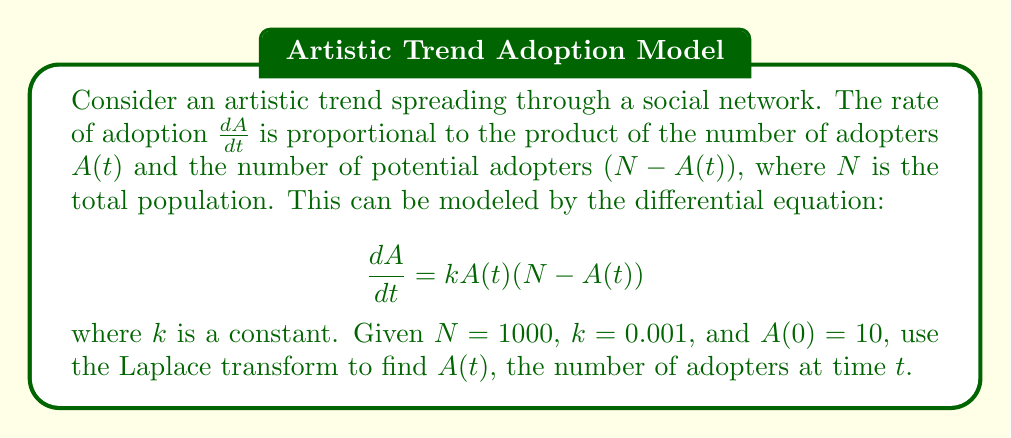Can you answer this question? Let's solve this step-by-step using the Laplace transform:

1) First, let's take the Laplace transform of both sides of the equation:

   $$\mathcal{L}\left\{\frac{dA}{dt}\right\} = \mathcal{L}\{kA(t)(N - A(t))\}$$

2) Using the linearity property and the fact that $\mathcal{L}\left\{\frac{dA}{dt}\right\} = s\mathcal{L}\{A(t)\} - A(0)$, we get:

   $$s\mathcal{L}\{A(t)\} - A(0) = kN\mathcal{L}\{A(t)\} - k\mathcal{L}\{A^2(t)\}$$

3) Let $\mathcal{L}\{A(t)\} = F(s)$. Then:

   $$sF(s) - 10 = 1000kF(s) - k\mathcal{L}\{A^2(t)\}$$

4) The term $\mathcal{L}\{A^2(t)\}$ makes this equation nonlinear. To solve it, we can use the final value theorem, which states that for a well-behaved function, $\lim_{t \to \infty} A(t) = \lim_{s \to 0} sF(s)$.

5) As $t \to \infty$, we expect $A(t) \to N = 1000$. So:

   $$\lim_{s \to 0} sF(s) = 1000$$

6) Using this, we can approximate:

   $$\mathcal{L}\{A^2(t)\} \approx \frac{1000}{s}F(s)$$

7) Substituting this back into our equation:

   $$sF(s) - 10 = 1000kF(s) - k\frac{1000}{s}F(s)$$

8) Rearranging:

   $$F(s)(s - 1000k + \frac{1000k}{s}) = 10$$

9) Substituting the values $k = 0.001$ and solving for $F(s)$:

   $$F(s) = \frac{10s}{s^2 - s + 1}$$

10) This is the Laplace transform of:

    $$A(t) = \frac{1000}{1 + 99e^{-t}}$$

11) This is the logistic function, which is a common model for the spread of ideas or trends.
Answer: $A(t) = \frac{1000}{1 + 99e^{-t}}$ 